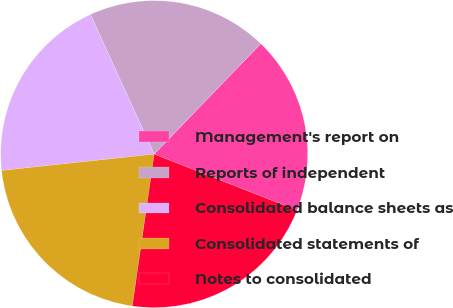Convert chart. <chart><loc_0><loc_0><loc_500><loc_500><pie_chart><fcel>Management's report on<fcel>Reports of independent<fcel>Consolidated balance sheets as<fcel>Consolidated statements of<fcel>Notes to consolidated<nl><fcel>18.75%<fcel>19.03%<fcel>19.89%<fcel>21.02%<fcel>21.31%<nl></chart> 